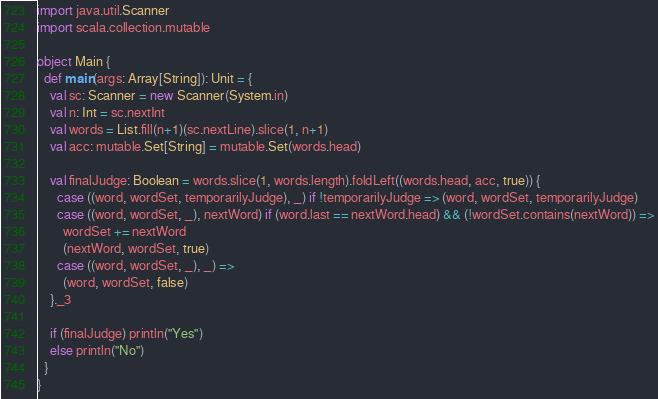<code> <loc_0><loc_0><loc_500><loc_500><_Scala_>import java.util.Scanner
import scala.collection.mutable

object Main {
  def main(args: Array[String]): Unit = {
    val sc: Scanner = new Scanner(System.in)
    val n: Int = sc.nextInt
    val words = List.fill(n+1)(sc.nextLine).slice(1, n+1)
    val acc: mutable.Set[String] = mutable.Set(words.head)

    val finalJudge: Boolean = words.slice(1, words.length).foldLeft((words.head, acc, true)) {
      case ((word, wordSet, temporarilyJudge), _) if !temporarilyJudge => (word, wordSet, temporarilyJudge)
      case ((word, wordSet, _), nextWord) if (word.last == nextWord.head) && (!wordSet.contains(nextWord)) =>
        wordSet += nextWord
        (nextWord, wordSet, true)
      case ((word, wordSet, _), _) =>
        (word, wordSet, false)
    }._3

    if (finalJudge) println("Yes")
    else println("No")
  }
}
</code> 